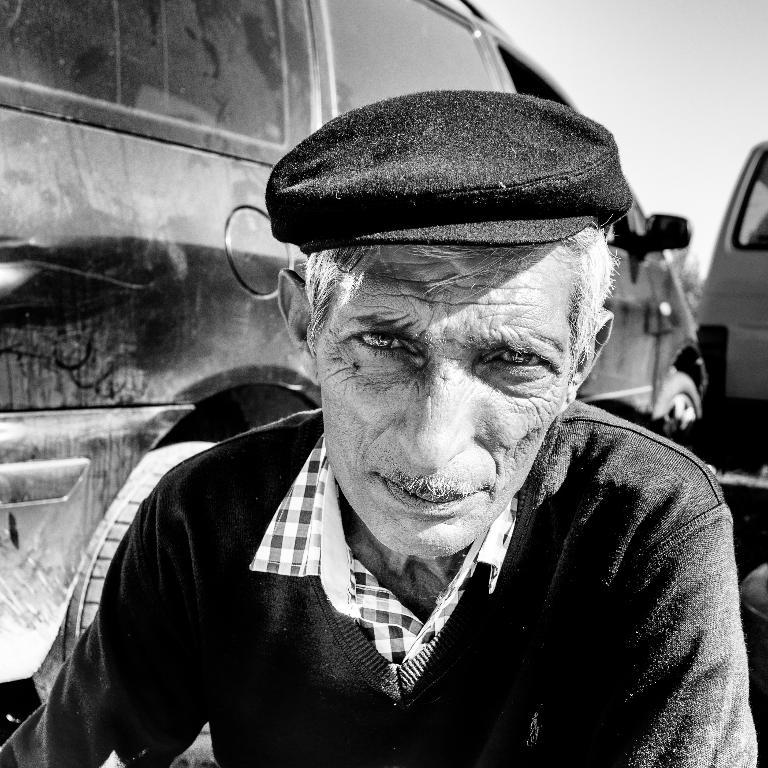What is the color scheme of the image? The image is black and white. Who or what is the main subject in the image? There is a person in the center of the image. What is the person wearing on their head? The person is wearing a cap. What can be seen behind the person? There is a car behind the person. How many toes can be seen on the person's foot in the image? There are no visible toes in the image, as the person is wearing a cap and standing in front of a car. Is there a sink visible in the image? No, there is no sink present in the image. 